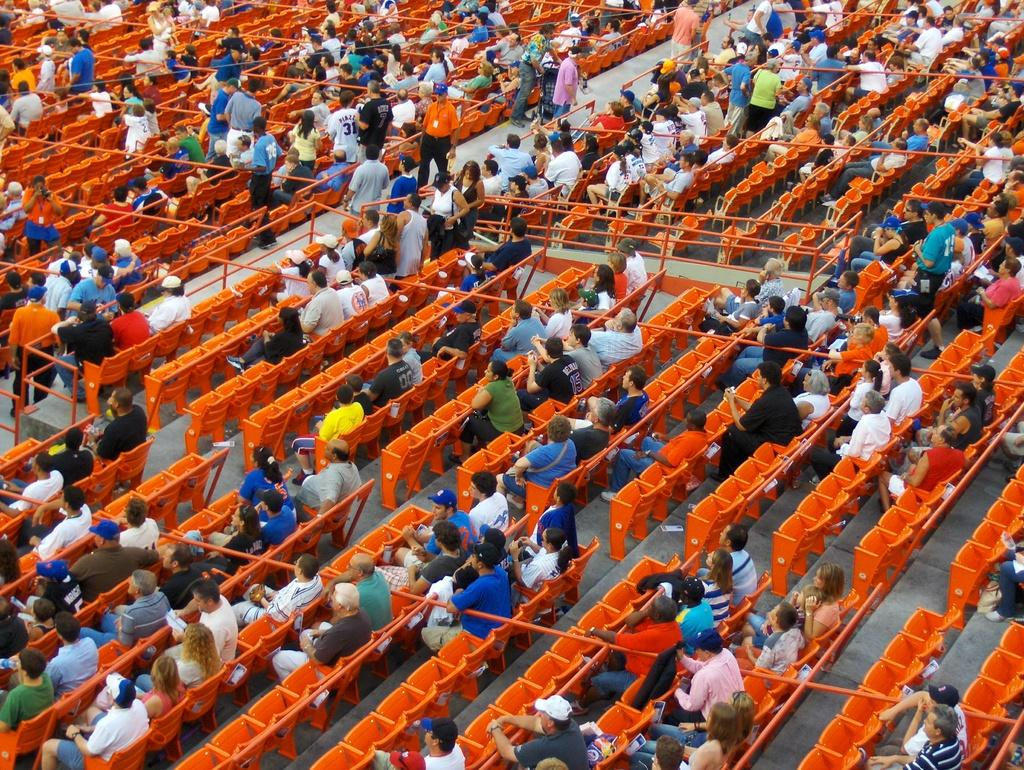What are the people in the image doing? There are groups of people sitting on chairs and standing in the image. Can you describe the rods visible in the image? Unfortunately, the facts provided do not give any details about the rods. However, we can confirm that rods are visible in the image. What type of apparatus is being used by the organization in the image? There is no apparatus or organization mentioned in the image. The image only shows groups of people sitting and standing, along with rods. 